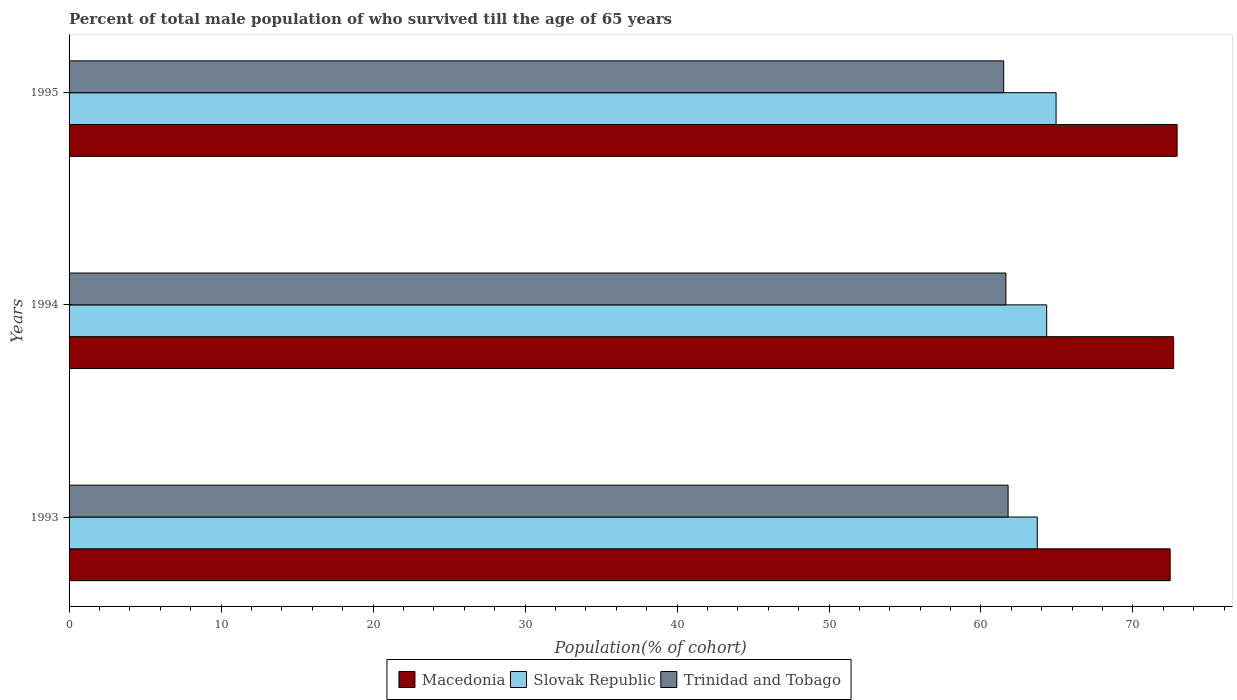What is the label of the 1st group of bars from the top?
Give a very brief answer. 1995. What is the percentage of total male population who survived till the age of 65 years in Trinidad and Tobago in 1995?
Your answer should be compact. 61.49. Across all years, what is the maximum percentage of total male population who survived till the age of 65 years in Trinidad and Tobago?
Your answer should be compact. 61.79. Across all years, what is the minimum percentage of total male population who survived till the age of 65 years in Slovak Republic?
Make the answer very short. 63.7. In which year was the percentage of total male population who survived till the age of 65 years in Macedonia maximum?
Your answer should be very brief. 1995. In which year was the percentage of total male population who survived till the age of 65 years in Slovak Republic minimum?
Your answer should be very brief. 1993. What is the total percentage of total male population who survived till the age of 65 years in Slovak Republic in the graph?
Your answer should be compact. 192.97. What is the difference between the percentage of total male population who survived till the age of 65 years in Macedonia in 1993 and that in 1994?
Provide a succinct answer. -0.23. What is the difference between the percentage of total male population who survived till the age of 65 years in Macedonia in 1994 and the percentage of total male population who survived till the age of 65 years in Trinidad and Tobago in 1993?
Ensure brevity in your answer.  10.89. What is the average percentage of total male population who survived till the age of 65 years in Slovak Republic per year?
Provide a short and direct response. 64.32. In the year 1994, what is the difference between the percentage of total male population who survived till the age of 65 years in Macedonia and percentage of total male population who survived till the age of 65 years in Slovak Republic?
Your answer should be very brief. 8.35. In how many years, is the percentage of total male population who survived till the age of 65 years in Macedonia greater than 10 %?
Your response must be concise. 3. What is the ratio of the percentage of total male population who survived till the age of 65 years in Macedonia in 1993 to that in 1994?
Keep it short and to the point. 1. Is the difference between the percentage of total male population who survived till the age of 65 years in Macedonia in 1993 and 1994 greater than the difference between the percentage of total male population who survived till the age of 65 years in Slovak Republic in 1993 and 1994?
Your answer should be very brief. Yes. What is the difference between the highest and the second highest percentage of total male population who survived till the age of 65 years in Trinidad and Tobago?
Your answer should be very brief. 0.15. What is the difference between the highest and the lowest percentage of total male population who survived till the age of 65 years in Trinidad and Tobago?
Provide a short and direct response. 0.29. In how many years, is the percentage of total male population who survived till the age of 65 years in Macedonia greater than the average percentage of total male population who survived till the age of 65 years in Macedonia taken over all years?
Give a very brief answer. 2. What does the 2nd bar from the top in 1995 represents?
Make the answer very short. Slovak Republic. What does the 3rd bar from the bottom in 1993 represents?
Provide a short and direct response. Trinidad and Tobago. Is it the case that in every year, the sum of the percentage of total male population who survived till the age of 65 years in Slovak Republic and percentage of total male population who survived till the age of 65 years in Macedonia is greater than the percentage of total male population who survived till the age of 65 years in Trinidad and Tobago?
Your answer should be compact. Yes. What is the difference between two consecutive major ticks on the X-axis?
Provide a succinct answer. 10. Are the values on the major ticks of X-axis written in scientific E-notation?
Your answer should be compact. No. How many legend labels are there?
Provide a succinct answer. 3. How are the legend labels stacked?
Your response must be concise. Horizontal. What is the title of the graph?
Provide a short and direct response. Percent of total male population of who survived till the age of 65 years. What is the label or title of the X-axis?
Offer a terse response. Population(% of cohort). What is the Population(% of cohort) in Macedonia in 1993?
Provide a succinct answer. 72.45. What is the Population(% of cohort) in Slovak Republic in 1993?
Provide a succinct answer. 63.7. What is the Population(% of cohort) in Trinidad and Tobago in 1993?
Offer a terse response. 61.79. What is the Population(% of cohort) of Macedonia in 1994?
Keep it short and to the point. 72.68. What is the Population(% of cohort) in Slovak Republic in 1994?
Offer a terse response. 64.32. What is the Population(% of cohort) in Trinidad and Tobago in 1994?
Offer a terse response. 61.64. What is the Population(% of cohort) of Macedonia in 1995?
Offer a very short reply. 72.9. What is the Population(% of cohort) of Slovak Republic in 1995?
Keep it short and to the point. 64.94. What is the Population(% of cohort) of Trinidad and Tobago in 1995?
Your answer should be compact. 61.49. Across all years, what is the maximum Population(% of cohort) of Macedonia?
Give a very brief answer. 72.9. Across all years, what is the maximum Population(% of cohort) of Slovak Republic?
Make the answer very short. 64.94. Across all years, what is the maximum Population(% of cohort) in Trinidad and Tobago?
Give a very brief answer. 61.79. Across all years, what is the minimum Population(% of cohort) in Macedonia?
Provide a succinct answer. 72.45. Across all years, what is the minimum Population(% of cohort) of Slovak Republic?
Your answer should be very brief. 63.7. Across all years, what is the minimum Population(% of cohort) of Trinidad and Tobago?
Your response must be concise. 61.49. What is the total Population(% of cohort) of Macedonia in the graph?
Your answer should be compact. 218.03. What is the total Population(% of cohort) in Slovak Republic in the graph?
Ensure brevity in your answer.  192.97. What is the total Population(% of cohort) in Trinidad and Tobago in the graph?
Offer a very short reply. 184.92. What is the difference between the Population(% of cohort) in Macedonia in 1993 and that in 1994?
Your answer should be very brief. -0.23. What is the difference between the Population(% of cohort) of Slovak Republic in 1993 and that in 1994?
Ensure brevity in your answer.  -0.62. What is the difference between the Population(% of cohort) of Trinidad and Tobago in 1993 and that in 1994?
Make the answer very short. 0.15. What is the difference between the Population(% of cohort) in Macedonia in 1993 and that in 1995?
Keep it short and to the point. -0.46. What is the difference between the Population(% of cohort) in Slovak Republic in 1993 and that in 1995?
Make the answer very short. -1.24. What is the difference between the Population(% of cohort) in Trinidad and Tobago in 1993 and that in 1995?
Offer a terse response. 0.29. What is the difference between the Population(% of cohort) in Macedonia in 1994 and that in 1995?
Provide a short and direct response. -0.23. What is the difference between the Population(% of cohort) in Slovak Republic in 1994 and that in 1995?
Make the answer very short. -0.62. What is the difference between the Population(% of cohort) in Trinidad and Tobago in 1994 and that in 1995?
Provide a short and direct response. 0.15. What is the difference between the Population(% of cohort) in Macedonia in 1993 and the Population(% of cohort) in Slovak Republic in 1994?
Offer a very short reply. 8.12. What is the difference between the Population(% of cohort) of Macedonia in 1993 and the Population(% of cohort) of Trinidad and Tobago in 1994?
Your answer should be compact. 10.81. What is the difference between the Population(% of cohort) of Slovak Republic in 1993 and the Population(% of cohort) of Trinidad and Tobago in 1994?
Your response must be concise. 2.06. What is the difference between the Population(% of cohort) in Macedonia in 1993 and the Population(% of cohort) in Slovak Republic in 1995?
Your response must be concise. 7.51. What is the difference between the Population(% of cohort) of Macedonia in 1993 and the Population(% of cohort) of Trinidad and Tobago in 1995?
Your answer should be compact. 10.95. What is the difference between the Population(% of cohort) of Slovak Republic in 1993 and the Population(% of cohort) of Trinidad and Tobago in 1995?
Provide a short and direct response. 2.21. What is the difference between the Population(% of cohort) in Macedonia in 1994 and the Population(% of cohort) in Slovak Republic in 1995?
Offer a very short reply. 7.73. What is the difference between the Population(% of cohort) in Macedonia in 1994 and the Population(% of cohort) in Trinidad and Tobago in 1995?
Make the answer very short. 11.18. What is the difference between the Population(% of cohort) in Slovak Republic in 1994 and the Population(% of cohort) in Trinidad and Tobago in 1995?
Your answer should be very brief. 2.83. What is the average Population(% of cohort) in Macedonia per year?
Provide a short and direct response. 72.68. What is the average Population(% of cohort) of Slovak Republic per year?
Provide a short and direct response. 64.32. What is the average Population(% of cohort) in Trinidad and Tobago per year?
Your answer should be compact. 61.64. In the year 1993, what is the difference between the Population(% of cohort) in Macedonia and Population(% of cohort) in Slovak Republic?
Ensure brevity in your answer.  8.74. In the year 1993, what is the difference between the Population(% of cohort) of Macedonia and Population(% of cohort) of Trinidad and Tobago?
Give a very brief answer. 10.66. In the year 1993, what is the difference between the Population(% of cohort) of Slovak Republic and Population(% of cohort) of Trinidad and Tobago?
Give a very brief answer. 1.92. In the year 1994, what is the difference between the Population(% of cohort) of Macedonia and Population(% of cohort) of Slovak Republic?
Offer a terse response. 8.35. In the year 1994, what is the difference between the Population(% of cohort) of Macedonia and Population(% of cohort) of Trinidad and Tobago?
Your answer should be very brief. 11.04. In the year 1994, what is the difference between the Population(% of cohort) in Slovak Republic and Population(% of cohort) in Trinidad and Tobago?
Provide a short and direct response. 2.68. In the year 1995, what is the difference between the Population(% of cohort) of Macedonia and Population(% of cohort) of Slovak Republic?
Offer a terse response. 7.96. In the year 1995, what is the difference between the Population(% of cohort) of Macedonia and Population(% of cohort) of Trinidad and Tobago?
Keep it short and to the point. 11.41. In the year 1995, what is the difference between the Population(% of cohort) in Slovak Republic and Population(% of cohort) in Trinidad and Tobago?
Your answer should be compact. 3.45. What is the ratio of the Population(% of cohort) in Macedonia in 1993 to that in 1994?
Offer a very short reply. 1. What is the ratio of the Population(% of cohort) of Slovak Republic in 1993 to that in 1994?
Give a very brief answer. 0.99. What is the ratio of the Population(% of cohort) of Macedonia in 1993 to that in 1995?
Provide a succinct answer. 0.99. What is the ratio of the Population(% of cohort) of Slovak Republic in 1993 to that in 1995?
Your response must be concise. 0.98. What is the ratio of the Population(% of cohort) of Trinidad and Tobago in 1993 to that in 1995?
Offer a very short reply. 1. What is the ratio of the Population(% of cohort) of Trinidad and Tobago in 1994 to that in 1995?
Make the answer very short. 1. What is the difference between the highest and the second highest Population(% of cohort) of Macedonia?
Your answer should be compact. 0.23. What is the difference between the highest and the second highest Population(% of cohort) of Slovak Republic?
Your answer should be very brief. 0.62. What is the difference between the highest and the second highest Population(% of cohort) of Trinidad and Tobago?
Offer a very short reply. 0.15. What is the difference between the highest and the lowest Population(% of cohort) in Macedonia?
Offer a very short reply. 0.46. What is the difference between the highest and the lowest Population(% of cohort) of Slovak Republic?
Keep it short and to the point. 1.24. What is the difference between the highest and the lowest Population(% of cohort) of Trinidad and Tobago?
Offer a very short reply. 0.29. 